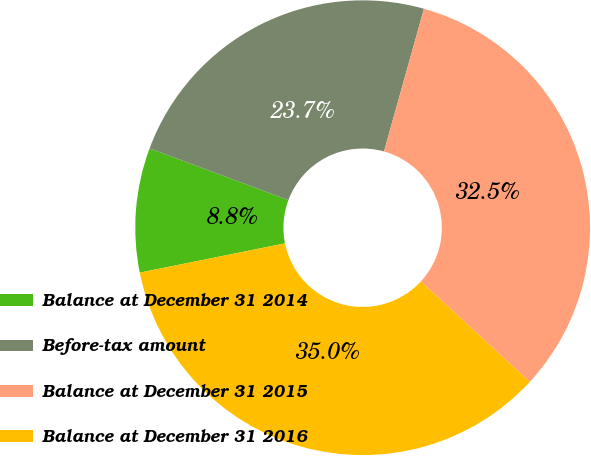<chart> <loc_0><loc_0><loc_500><loc_500><pie_chart><fcel>Balance at December 31 2014<fcel>Before-tax amount<fcel>Balance at December 31 2015<fcel>Balance at December 31 2016<nl><fcel>8.84%<fcel>23.67%<fcel>32.51%<fcel>34.98%<nl></chart> 